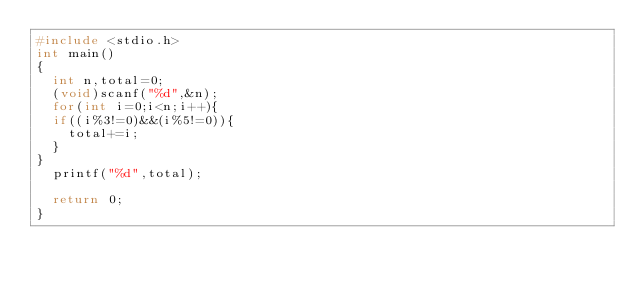<code> <loc_0><loc_0><loc_500><loc_500><_C_>#include <stdio.h>
int main()
{
  int n,total=0;
  (void)scanf("%d",&n);
  for(int i=0;i<n;i++){
  if((i%3!=0)&&(i%5!=0)){
    total+=i;
  }
}
  printf("%d",total);

  return 0;
}</code> 